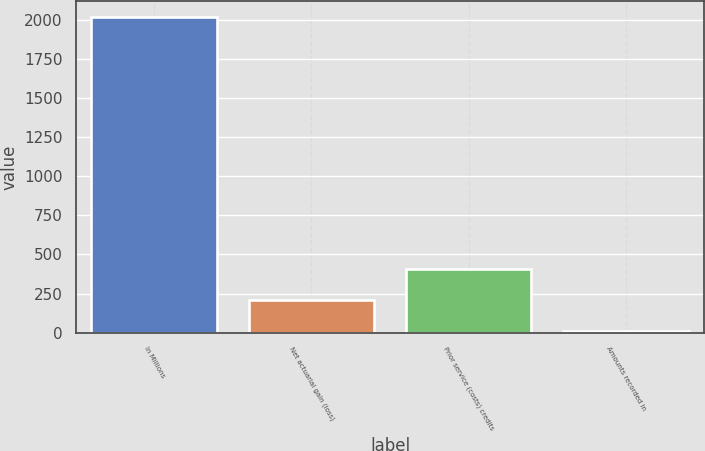<chart> <loc_0><loc_0><loc_500><loc_500><bar_chart><fcel>In Millions<fcel>Net actuarial gain (loss)<fcel>Prior service (costs) credits<fcel>Amounts recorded in<nl><fcel>2017<fcel>209.17<fcel>410.04<fcel>8.3<nl></chart> 